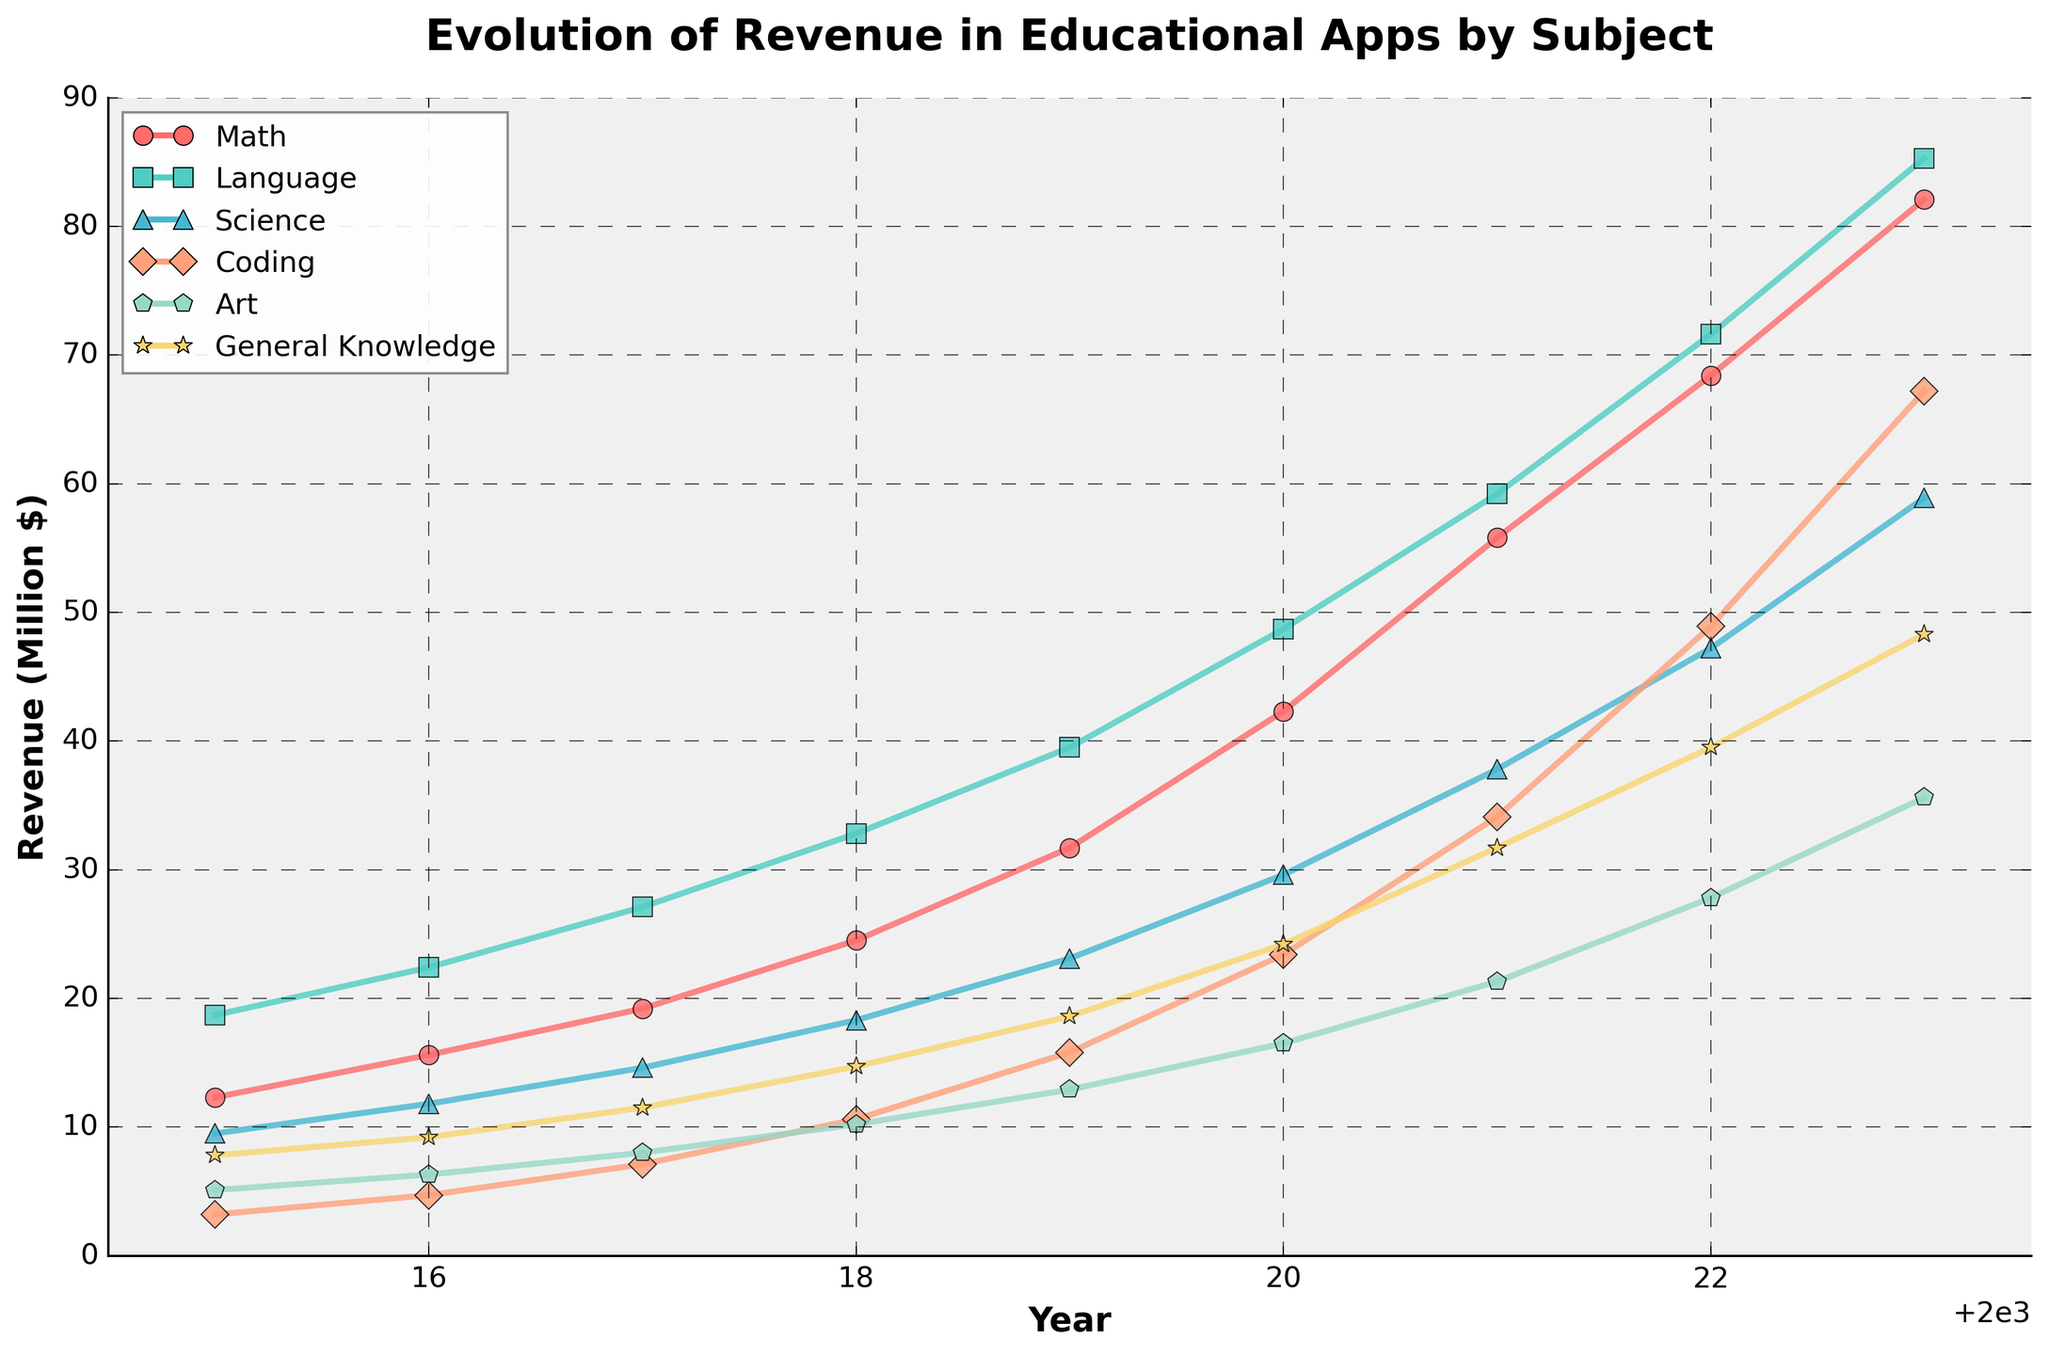Which subject area had the highest revenue in 2023? Looking at the data for the year 2023 across all subject areas, the highest revenue is from the subject 'Math' with a value of 82.1 million dollars.
Answer: Math How much total revenue was generated by all subject areas in 2020? Sum the values across all subject areas for the year 2020: 42.3 (Math) + 48.7 (Language) + 29.6 (Science) + 23.4 (Coding) + 16.5 (Art) + 24.2 (General Knowledge) = 184.7 million dollars.
Answer: 184.7 Which subject areas showed a consistent increase in revenue from 2015 to 2023? Examining each subject from 2015 to 2023: Math, Language, Science, Coding, Art, and General Knowledge all show a consistent increase every year in their respective revenues.
Answer: Math, Language, Science, Coding, Art, General Knowledge What is the average annual revenue growth for the Language subject from 2015 to 2023? Calculate the revenue increase for Language from 2015 to 2023: (85.3 - 18.7) = 66.6 million dollars. Divide this by the number of years: 66.6 / (2023 - 2015) = 66.6 / 8 = 8.325 million dollars per year on average.
Answer: 8.325 Which subject had the lowest revenue in 2019 and how much was it? Reviewing the data for 2019, 'Art' had the lowest revenue with 12.9 million dollars.
Answer: Art, 12.9 Compare the revenue growth between Coding and Art from 2018 to 2023. Which subject grew more and by how much? Calculate the growth for Coding: 67.2 (2023) - 10.6 (2018) = 56.6 million dollars. Calculate the growth for Art: 35.6 (2023) - 10.2 (2018) = 25.4 million dollars. The difference in growth: 56.6 - 25.4 = 31.2 million dollars. Coding grew more by 31.2 million dollars.
Answer: Coding, 31.2 In which year did General Knowledge and Coding revenues become equal, and how much was it? In 2017, both General Knowledge and Coding revenues were 11.5 million dollars.
Answer: 2017, 11.5 Which subject had the sharpest increase in revenue from 2015 to 2023? Calculate the revenue increase for each subject from 2015 to 2023: Math (82.1 - 12.3 = 69.8), Language (85.3 - 18.7 = 66.6), Science (58.9 - 9.5 = 49.4), Coding (67.2 - 3.2 = 64), Art (35.6 - 5.1 = 30.5), General Knowledge (48.3 - 7.8 = 40.5). Math had the sharpest increase with 69.8 million dollars.
Answer: Math 